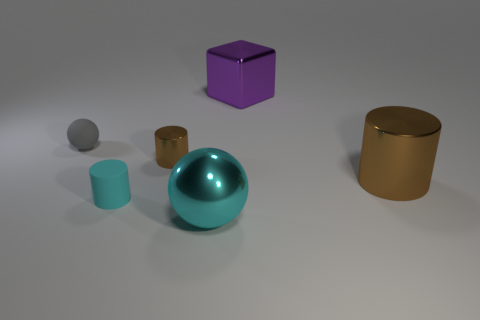What can the arrangement of objects tell us about the possible context or purpose of this setup? The arrangement of objects in the image appears deliberate, suggesting a set-up for a study of geometry, material properties, or lighting effects. The variety of colors, shapes, and materials may indicate an exercise in digital rendering or photography composition, possibly testing how different textures reflect or absorb light. The clear spacing between the objects shows each one's characteristics distinctly, which might be ideal for educational purposes or visual analysis in a 3D modeling software environment. 